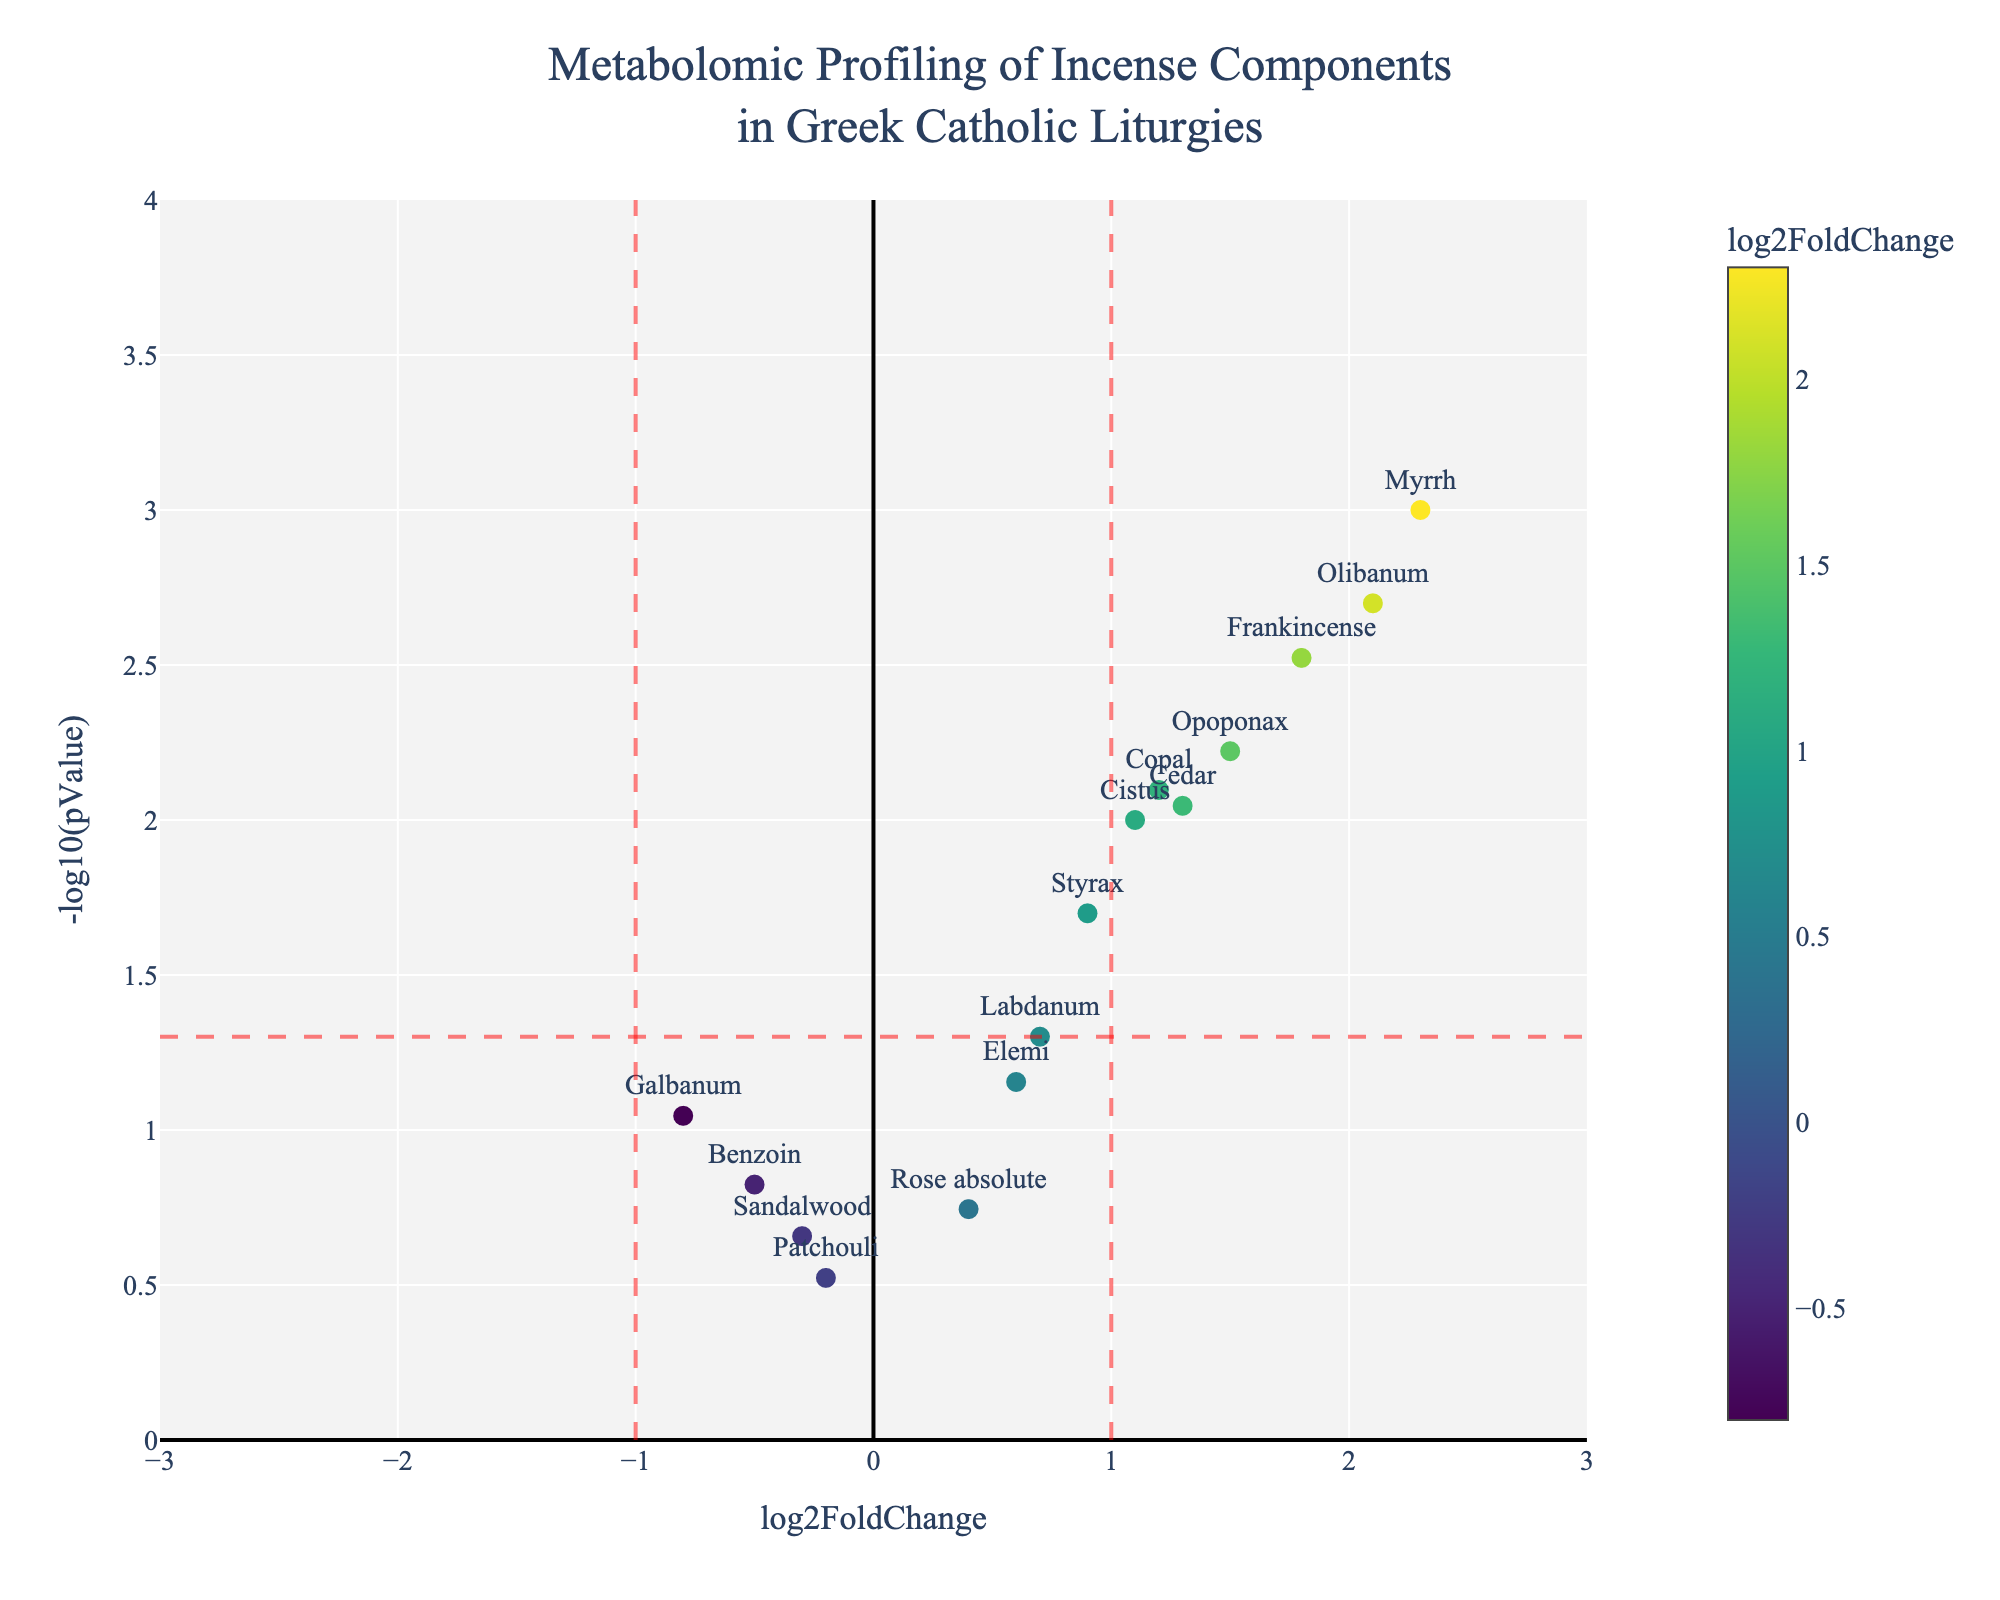what is the title of the figure? The title can be found at the top of the plot and often provides context about the figure. Here, it reads: "Metabolomic Profiling of Incense Components in Greek Catholic Liturgies."
Answer: Metabolomic Profiling of Incense Components in Greek Catholic Liturgies How many compounds have a log2FoldChange greater than 1? To answer this, count the markers (points) right of the vertical line at log2FoldChange = 1. From the data: Myrrh, Frankincense, Olibanum, Opoponax, Copal, Cedar.
Answer: 6 Which compound has the highest log2FoldChange and what is its value? Identify the point farthest to the right along the x-axis (log2FoldChange). Myrrh is the farthest right, with a log2FoldChange of 2.3.
Answer: Myrrh, 2.3 Which compound has the lowest pValue and what is its corresponding -log10(pValue)? The lowest pValue corresponds to the highest value on the y-axis (-log10(pValue)). Here, it is Myrrh with the highest point at ~ -log10(0.001) = 3.
Answer: Myrrh, ~3 Is there any compound with a log2FoldChange less than -1 and a statistically significant pValue (p < 0.05)? Look for points left of the vertical line at log2FoldChange = -1 and above the horizontal line at -log10(pValue) = 1.3 (p = 0.05). From the plot, no such points exist.
Answer: No Which compounds have both log2FoldChange greater than 1 and statistically significant pValue (p < 0.05)? Identify the points right of the log2FoldChange = 1 line and above the -log10(pValue) = 1.3 line: Myrrh, Frankincense, Olibanum, Opoponax, Copal, Cedar.
Answer: Myrrh, Frankincense, Olibanum, Opoponax, Copal, Cedar What's the range of log2FoldChange values? The range can be found by subtracting the smallest log2FoldChange from the largest. From the plot: highest is Myrrh (2.3), lowest is Galbanum (-0.8). Range = 2.3 - (-0.8) = 3.1
Answer: 3.1 Which compound has a log2FoldChange closest to zero and what is its pValue? Among the plotted points, Patchouli has the log2FoldChange closest to zero with a value of -0.2. Its pValue is approximately 0.3.
Answer: Patchouli, ~0.3 